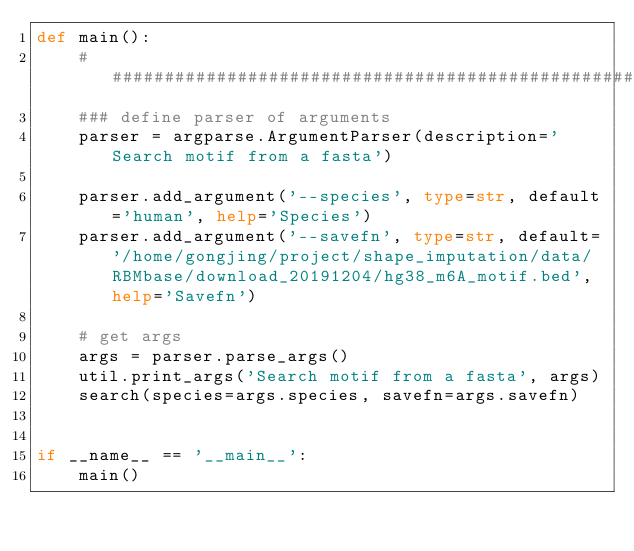Convert code to text. <code><loc_0><loc_0><loc_500><loc_500><_Python_>def main():
    ####################################################################
    ### define parser of arguments
    parser = argparse.ArgumentParser(description='Search motif from a fasta')
    
    parser.add_argument('--species', type=str, default='human', help='Species')
    parser.add_argument('--savefn', type=str, default='/home/gongjing/project/shape_imputation/data/RBMbase/download_20191204/hg38_m6A_motif.bed', help='Savefn')
    
    # get args
    args = parser.parse_args()
    util.print_args('Search motif from a fasta', args)
    search(species=args.species, savefn=args.savefn)
    

if __name__ == '__main__':
    main()</code> 